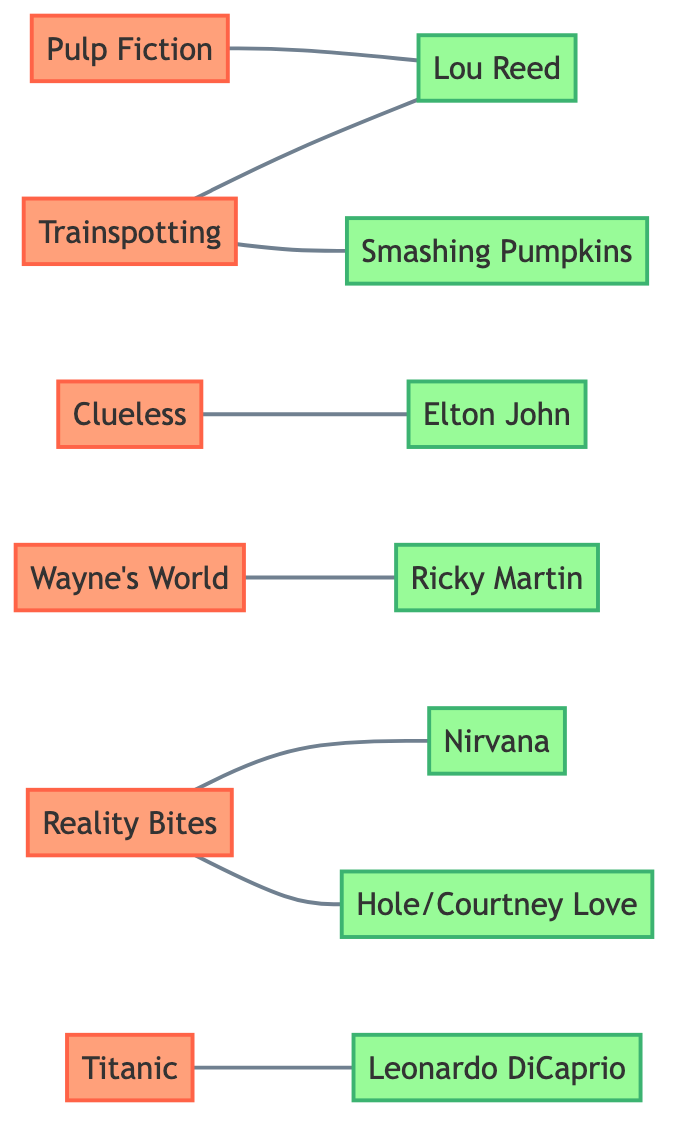What movie is associated with Lou Reed? The diagram shows that Lou Reed is connected to both "Pulp Fiction" and "Trainspotting." Thus, either movie can be an answer, but just one can be specified based on the request.
Answer: Pulp Fiction How many movies are represented in the graph? The nodes labeled as movies include "Pulp Fiction," "Trainspotting," "Clueless," "Wayne's World," "Reality Bites," and "Titanic." Counting these gives a total of six movies.
Answer: 6 Which artist is connected to both Reality Bites and Hole/Courtney Love? The connection in the diagram indicates that Reality Bites is directly connected to Hole/Courtney Love and also has a direct link to Nirvana. The question specifically asks about an artist linked to both, which identifies Hole/Courtney Love as that artist.
Answer: Hole/Courtney Love Is there a movie associated with both Smashing Pumpkins and Lou Reed? The graph shows that "Trainspotting" is connected to both Smashing Pumpkins and Lou Reed. Thus, "Trainspotting" is the movie that fits both connections asked in the question.
Answer: Trainspotting How many edges connect the movies to artists in the graph? Each connection (or edge) between the nodes represents a relationship between a movie and an artist. By counting all connections, we find that there are a total of seven edges in the diagram.
Answer: 7 Which artist is uniquely connected to Titanic? In the diagram, "Titanic" is connected only to "Leonardo DiCaprio," indicating that he is the sole artist related to this movie, without any other connections.
Answer: Leonardo DiCaprio What is the relationship between Wayne's World and Ricky Martin? The graph shows a direct connection denoted by an edge between the movie "Wayne's World" and the artist Ricky Martin. This indicates that Ricky Martin is linked to Wayne's World through the soundtrack or contribution.
Answer: Ricky Martin Which two movies are associated with Lou Reed? The graph displays edges connecting Lou Reed to both "Pulp Fiction" and "Trainspotting". Thus, the answer must include both titles as they are relevant to the question posed.
Answer: Pulp Fiction, Trainspotting Which artist is linked to two movies? Looking at the connections, Hole/Courtney Love is linked to "Reality Bites" and also associated with the edge showing a connection for the artist within the same movie. This indicates he fits the criteria of an artist linked to two movies.
Answer: Hole/Courtney Love 